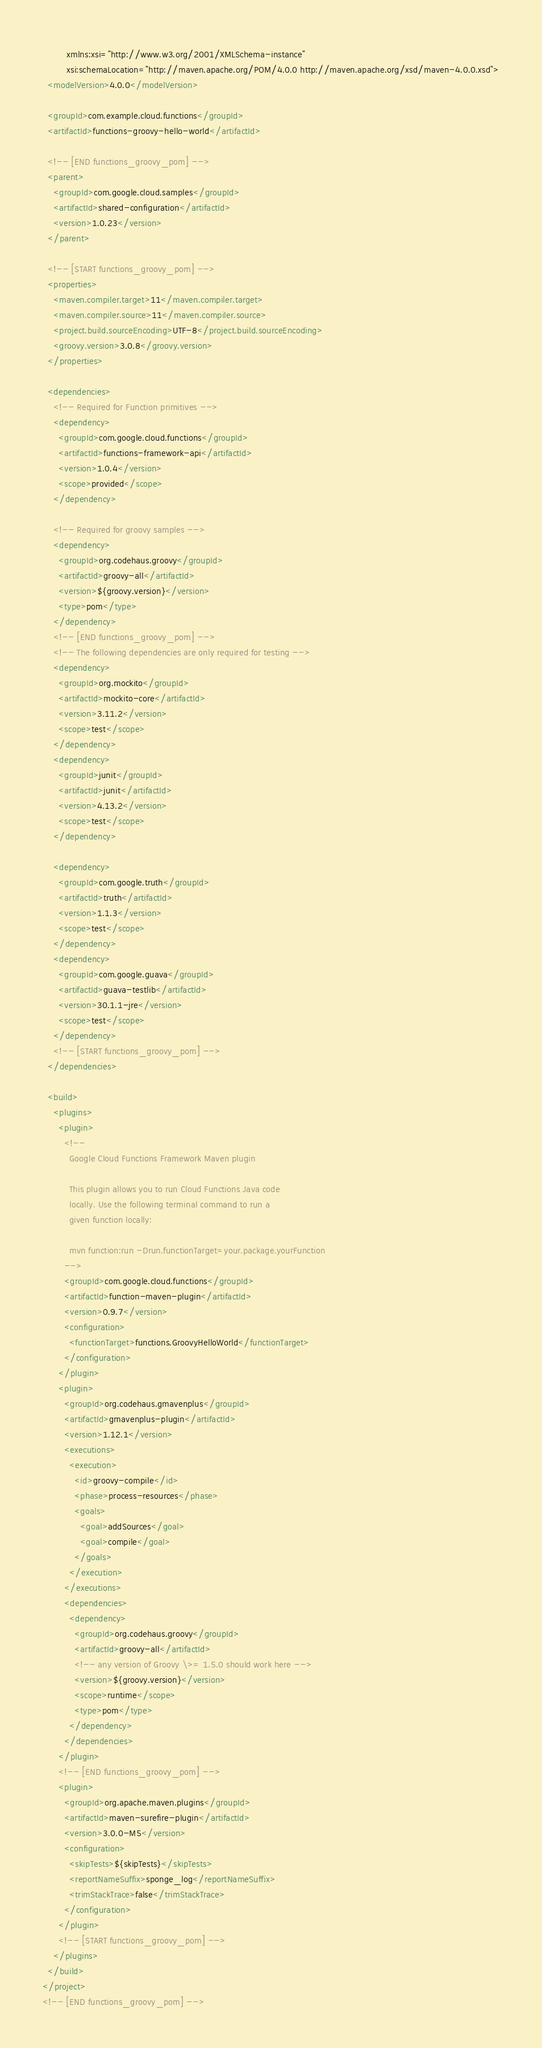<code> <loc_0><loc_0><loc_500><loc_500><_XML_>         xmlns:xsi="http://www.w3.org/2001/XMLSchema-instance"
         xsi:schemaLocation="http://maven.apache.org/POM/4.0.0 http://maven.apache.org/xsd/maven-4.0.0.xsd">
  <modelVersion>4.0.0</modelVersion>

  <groupId>com.example.cloud.functions</groupId>
  <artifactId>functions-groovy-hello-world</artifactId>
  
  <!-- [END functions_groovy_pom] -->
  <parent>
    <groupId>com.google.cloud.samples</groupId>
    <artifactId>shared-configuration</artifactId>
    <version>1.0.23</version>
  </parent>
  
  <!-- [START functions_groovy_pom] -->
  <properties>
    <maven.compiler.target>11</maven.compiler.target>
    <maven.compiler.source>11</maven.compiler.source>
    <project.build.sourceEncoding>UTF-8</project.build.sourceEncoding>
    <groovy.version>3.0.8</groovy.version>
  </properties>

  <dependencies>
    <!-- Required for Function primitives -->
    <dependency>
      <groupId>com.google.cloud.functions</groupId>
      <artifactId>functions-framework-api</artifactId>
      <version>1.0.4</version>
      <scope>provided</scope>
    </dependency>

    <!-- Required for groovy samples -->
    <dependency>
      <groupId>org.codehaus.groovy</groupId>
      <artifactId>groovy-all</artifactId>
      <version>${groovy.version}</version>
      <type>pom</type>
    </dependency>
    <!-- [END functions_groovy_pom] -->
    <!-- The following dependencies are only required for testing -->
    <dependency>
      <groupId>org.mockito</groupId>
      <artifactId>mockito-core</artifactId>
      <version>3.11.2</version>
      <scope>test</scope>
    </dependency>
    <dependency>
      <groupId>junit</groupId>
      <artifactId>junit</artifactId>
      <version>4.13.2</version>
      <scope>test</scope>
    </dependency>

    <dependency>
      <groupId>com.google.truth</groupId>
      <artifactId>truth</artifactId>
      <version>1.1.3</version>
      <scope>test</scope>
    </dependency>
    <dependency>
      <groupId>com.google.guava</groupId>
      <artifactId>guava-testlib</artifactId>
      <version>30.1.1-jre</version>
      <scope>test</scope>
    </dependency>
    <!-- [START functions_groovy_pom] -->
  </dependencies>
  
  <build>
    <plugins>
      <plugin>
        <!--
          Google Cloud Functions Framework Maven plugin

          This plugin allows you to run Cloud Functions Java code
          locally. Use the following terminal command to run a
          given function locally:

          mvn function:run -Drun.functionTarget=your.package.yourFunction
        -->
        <groupId>com.google.cloud.functions</groupId>
        <artifactId>function-maven-plugin</artifactId>
        <version>0.9.7</version>
        <configuration>
          <functionTarget>functions.GroovyHelloWorld</functionTarget>
        </configuration>
      </plugin>
      <plugin>
        <groupId>org.codehaus.gmavenplus</groupId>
        <artifactId>gmavenplus-plugin</artifactId>
        <version>1.12.1</version>
        <executions>
          <execution>
            <id>groovy-compile</id>
            <phase>process-resources</phase>
            <goals>
              <goal>addSources</goal>
              <goal>compile</goal>
            </goals>
          </execution>
        </executions>
        <dependencies>
          <dependency>
            <groupId>org.codehaus.groovy</groupId>
            <artifactId>groovy-all</artifactId>
            <!-- any version of Groovy \>= 1.5.0 should work here -->
            <version>${groovy.version}</version>
            <scope>runtime</scope>
            <type>pom</type>
          </dependency>
        </dependencies>
      </plugin>
      <!-- [END functions_groovy_pom] -->
      <plugin>
        <groupId>org.apache.maven.plugins</groupId>
        <artifactId>maven-surefire-plugin</artifactId>
        <version>3.0.0-M5</version>
        <configuration>
          <skipTests>${skipTests}</skipTests>
          <reportNameSuffix>sponge_log</reportNameSuffix>
          <trimStackTrace>false</trimStackTrace>
        </configuration>
      </plugin>
      <!-- [START functions_groovy_pom] -->
    </plugins>
  </build>
</project>
<!-- [END functions_groovy_pom] -->
</code> 